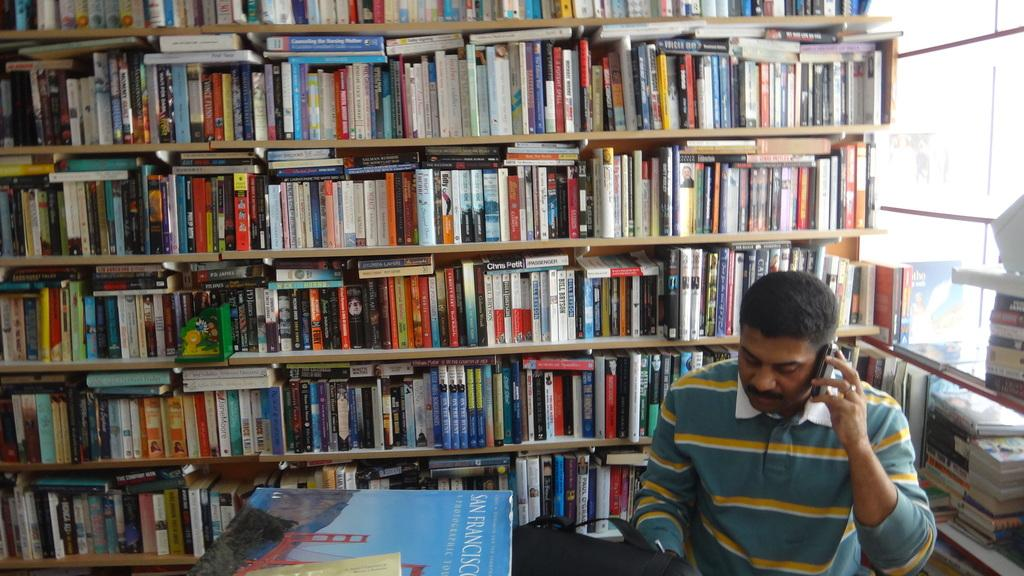Provide a one-sentence caption for the provided image. A man talks on his cell phone with a book about San Francisco on the table. 